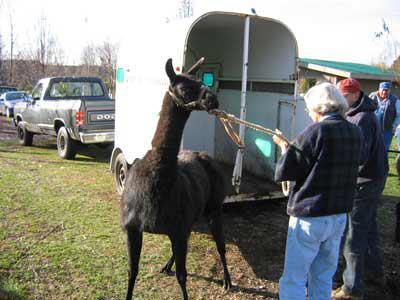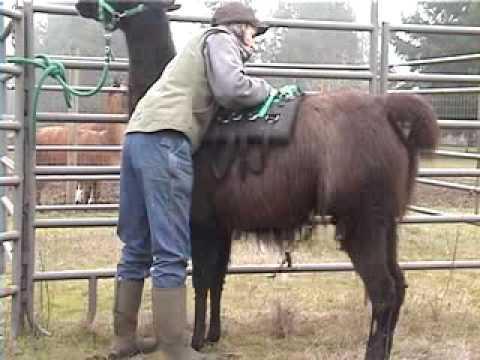The first image is the image on the left, the second image is the image on the right. Considering the images on both sides, is "An image shows a back-turned standing person on the right pulling a rope attached to a llama in front of an open wheeled hauler." valid? Answer yes or no. Yes. 